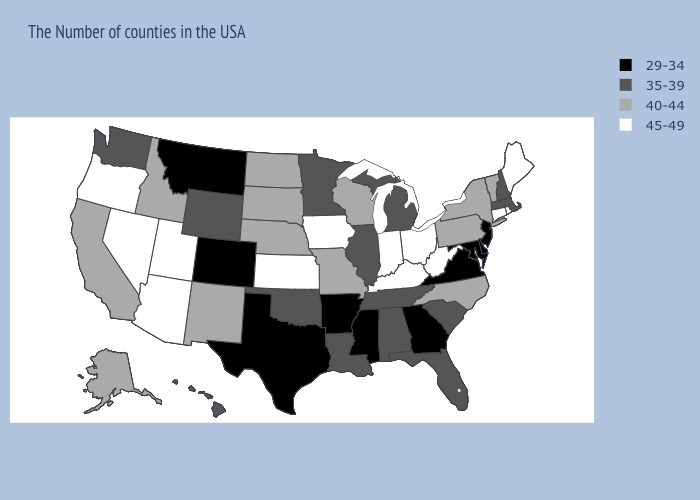What is the value of New Mexico?
Keep it brief. 40-44. What is the lowest value in the MidWest?
Give a very brief answer. 35-39. Name the states that have a value in the range 45-49?
Answer briefly. Maine, Rhode Island, Connecticut, West Virginia, Ohio, Kentucky, Indiana, Iowa, Kansas, Utah, Arizona, Nevada, Oregon. Name the states that have a value in the range 29-34?
Answer briefly. New Jersey, Delaware, Maryland, Virginia, Georgia, Mississippi, Arkansas, Texas, Colorado, Montana. What is the value of Nevada?
Be succinct. 45-49. Does the first symbol in the legend represent the smallest category?
Answer briefly. Yes. Does Minnesota have the lowest value in the MidWest?
Quick response, please. Yes. Does Wisconsin have the highest value in the USA?
Be succinct. No. Does Michigan have the lowest value in the USA?
Concise answer only. No. What is the value of Michigan?
Short answer required. 35-39. What is the value of Washington?
Write a very short answer. 35-39. Does Nebraska have a higher value than Georgia?
Be succinct. Yes. Does North Dakota have the highest value in the USA?
Concise answer only. No. Among the states that border Alabama , which have the lowest value?
Write a very short answer. Georgia, Mississippi. Name the states that have a value in the range 45-49?
Quick response, please. Maine, Rhode Island, Connecticut, West Virginia, Ohio, Kentucky, Indiana, Iowa, Kansas, Utah, Arizona, Nevada, Oregon. 